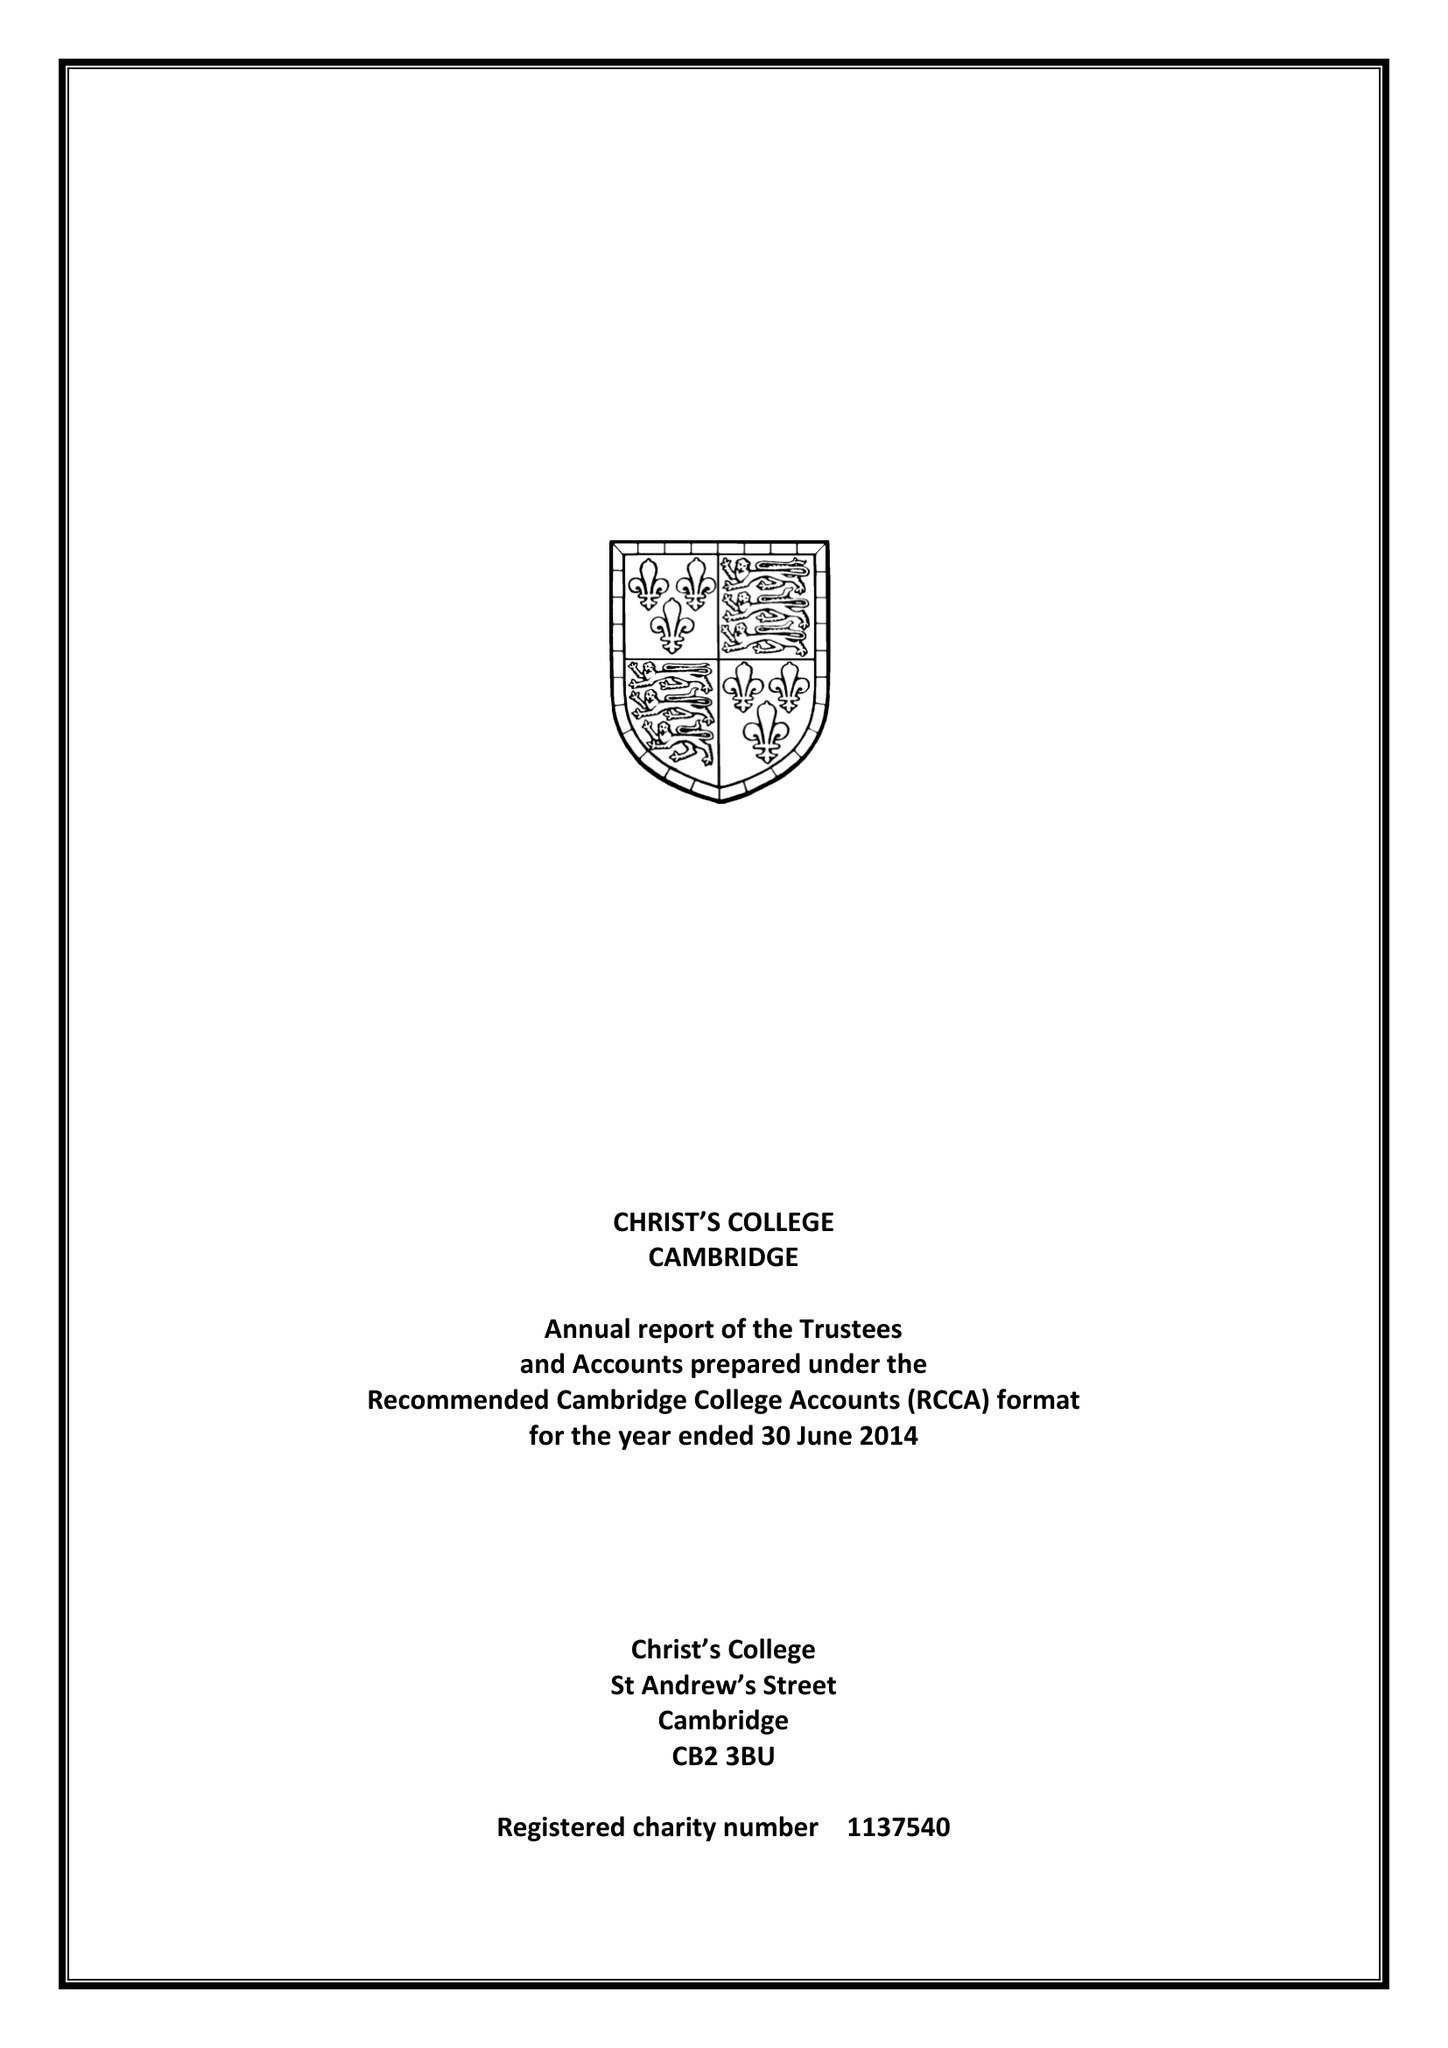What is the value for the income_annually_in_british_pounds?
Answer the question using a single word or phrase. 9792990.00 